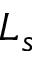<formula> <loc_0><loc_0><loc_500><loc_500>L _ { s }</formula> 